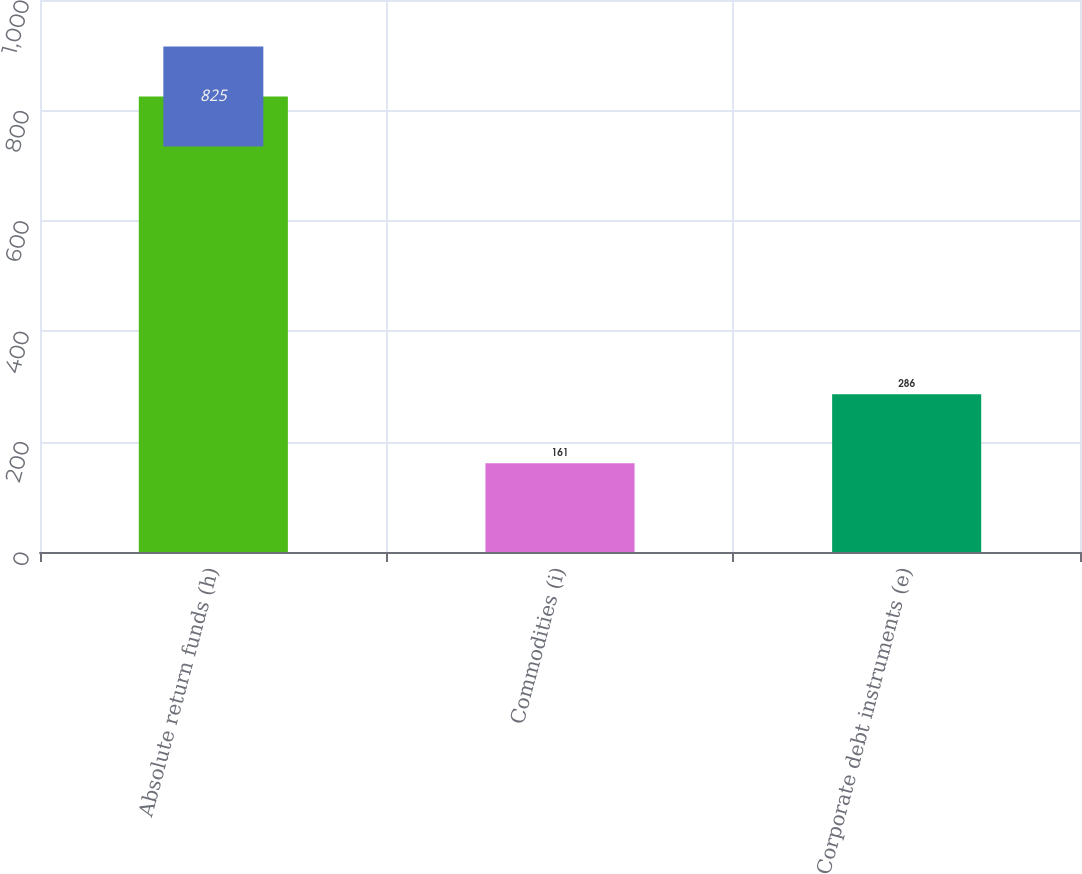Convert chart to OTSL. <chart><loc_0><loc_0><loc_500><loc_500><bar_chart><fcel>Absolute return funds (h)<fcel>Commodities (i)<fcel>Corporate debt instruments (e)<nl><fcel>825<fcel>161<fcel>286<nl></chart> 